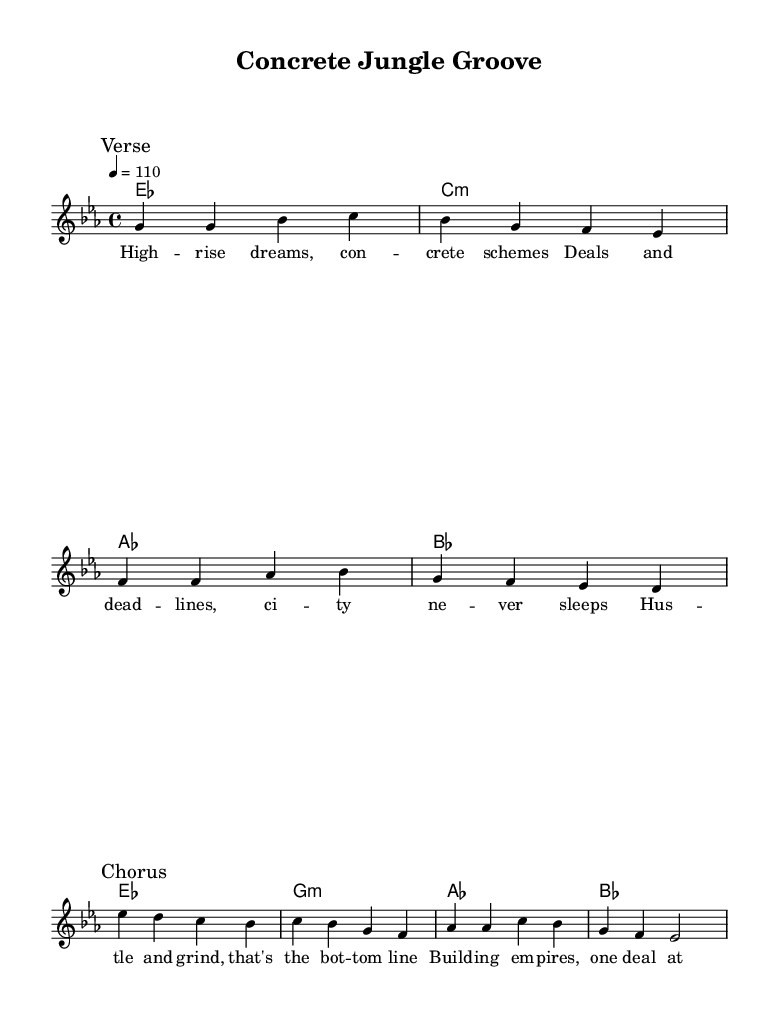What is the key signature of this music? The key signature is E flat major, which contains three flats (B flat, E flat, and A flat). This can be determined by looking at the key signature indicated at the beginning of the staff.
Answer: E flat major What is the time signature of this music? The time signature is 4/4, which means there are four beats in a measure and the quarter note gets one beat. This can be found right after the key signature at the beginning of the staff.
Answer: 4/4 What is the tempo marking of the piece? The tempo marking indicates a speed of 110 beats per minute, denoted as "4 = 110" at the beginning of the score. This tells the performer how fast to play the piece.
Answer: 110 How many measures are in the verse section? The verse section contains four measures, which can be counted by looking at the bar lines in the melody section corresponding to the verse.
Answer: 4 What is the main lyrical theme of the chorus? The main theme of the chorus revolves around the hustle and grind of business life, as indicated by the words "Hustle and grind, that's the bottom line." This captures the essence of the song's message.
Answer: Hustle and grind What chord follows the G minor chord in the harmonies? The chord that follows the G minor chord is A flat major, as shown in the chord progression that follows the G minor chord in the harmonies section.
Answer: A flat major What is the rhythmic pattern of the melody during the chorus? The rhythmic pattern in the chorus consists mainly of quarter notes, contributing to a steady groove that complements the lyrical content about building empires. This can be determined by analyzing the note values in the chorus melody.
Answer: Quarter notes 